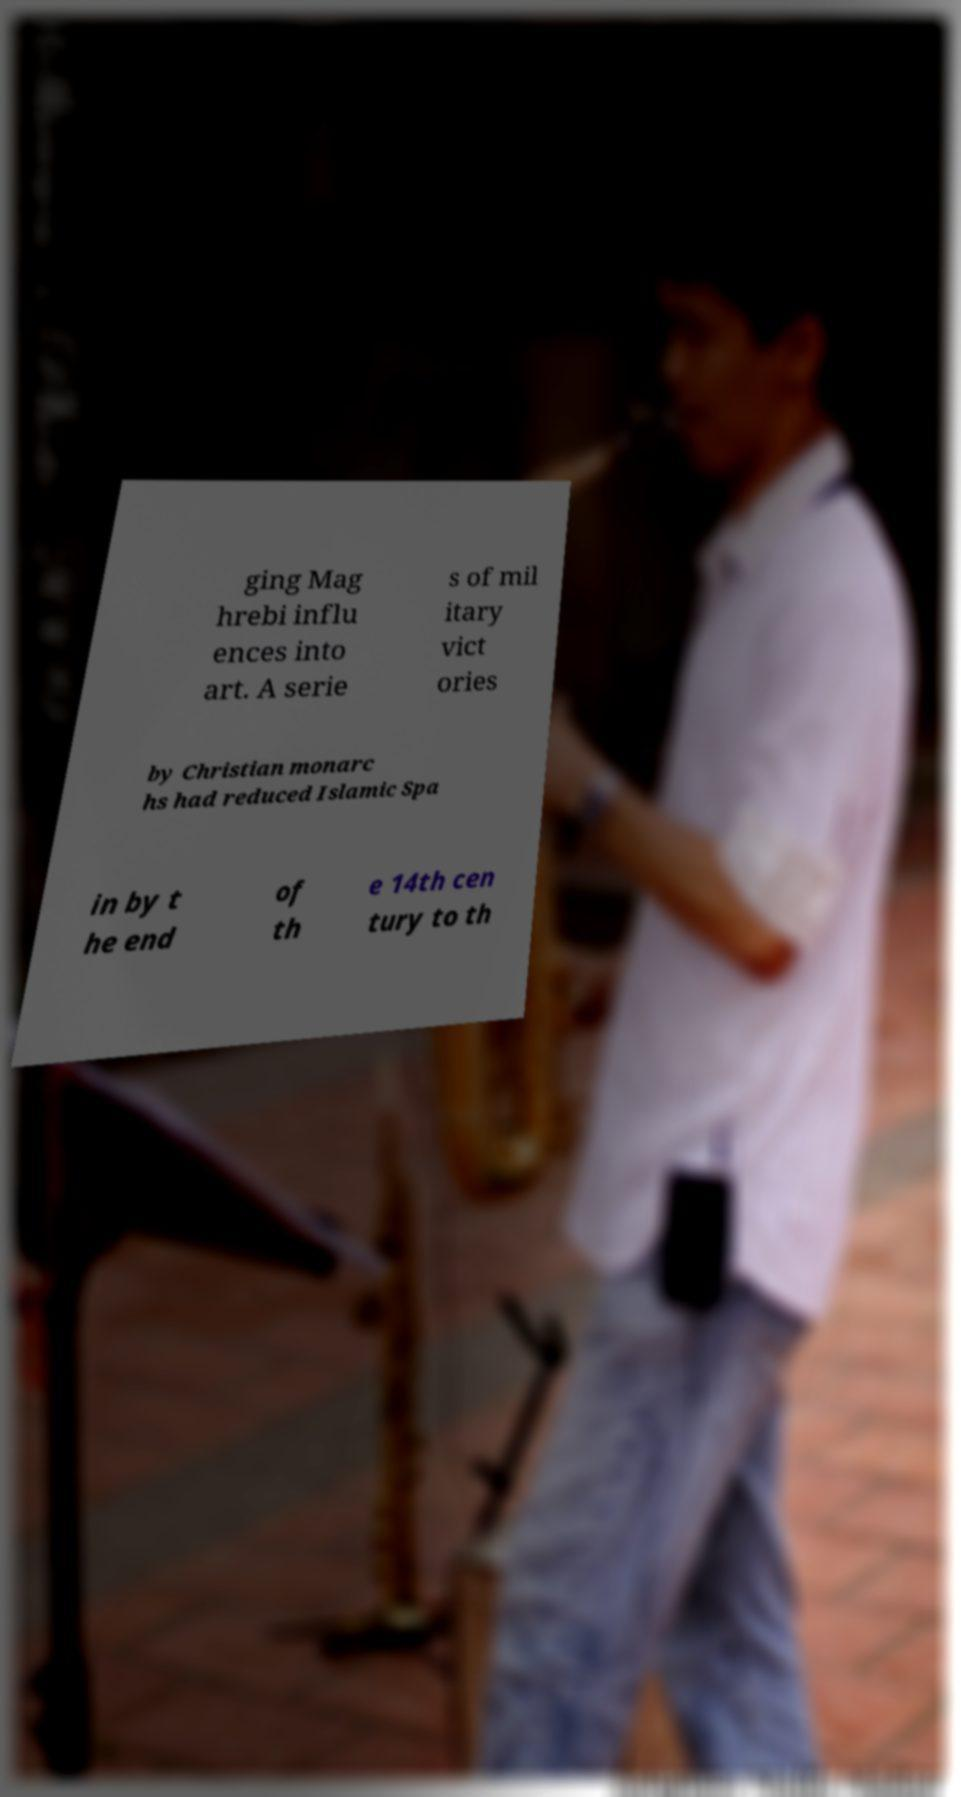Could you extract and type out the text from this image? ging Mag hrebi influ ences into art. A serie s of mil itary vict ories by Christian monarc hs had reduced Islamic Spa in by t he end of th e 14th cen tury to th 